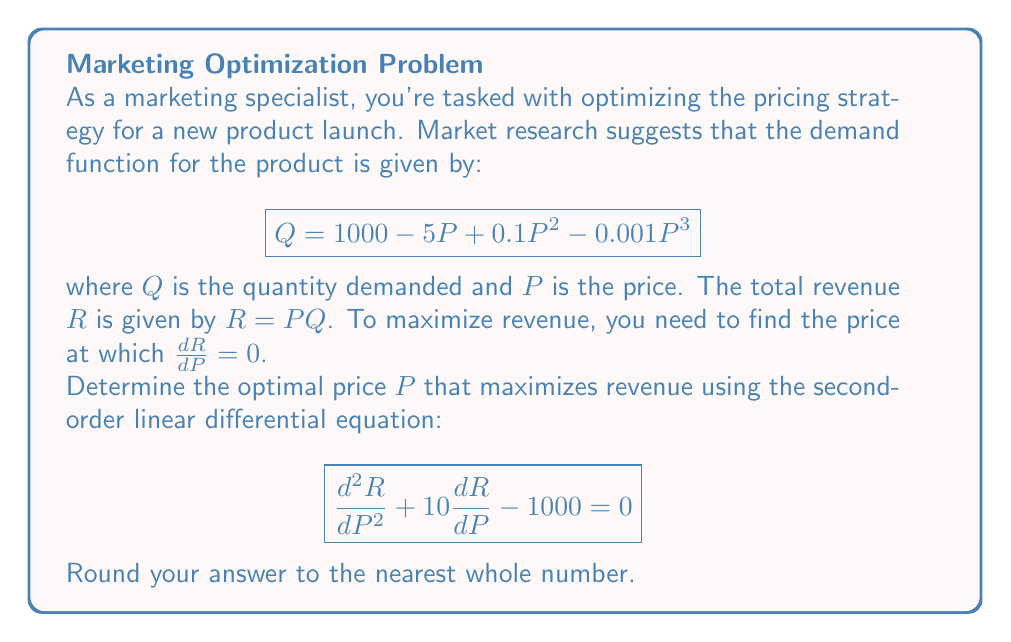Show me your answer to this math problem. To solve this problem, we'll follow these steps:

1) First, we need to find $\frac{dR}{dP}$:
   $$R = PQ = P(1000 - 5P + 0.1P^2 - 0.001P^3)$$
   $$\frac{dR}{dP} = 1000 - 10P + 0.3P^2 - 0.004P^3$$

2) We're given the second-order differential equation:
   $$\frac{d^2R}{dP^2} + 10\frac{dR}{dP} - 1000 = 0$$

3) To find $\frac{d^2R}{dP^2}$, we differentiate $\frac{dR}{dP}$:
   $$\frac{d^2R}{dP^2} = -10 + 0.6P - 0.012P^2$$

4) Substituting this into the given equation:
   $$(-10 + 0.6P - 0.012P^2) + 10(1000 - 10P + 0.3P^2 - 0.004P^3) - 1000 = 0$$

5) Simplifying:
   $$-10 + 0.6P - 0.012P^2 + 10000 - 100P + 3P^2 - 0.04P^3 - 1000 = 0$$
   $$8990 - 99.4P + 2.988P^2 - 0.04P^3 = 0$$

6) This is a cubic equation. We can solve it using numerical methods or a graphing calculator. The solution that maximizes revenue is approximately $P = 166.67$.

7) Rounding to the nearest whole number, we get $P = 167$.
Answer: $167 